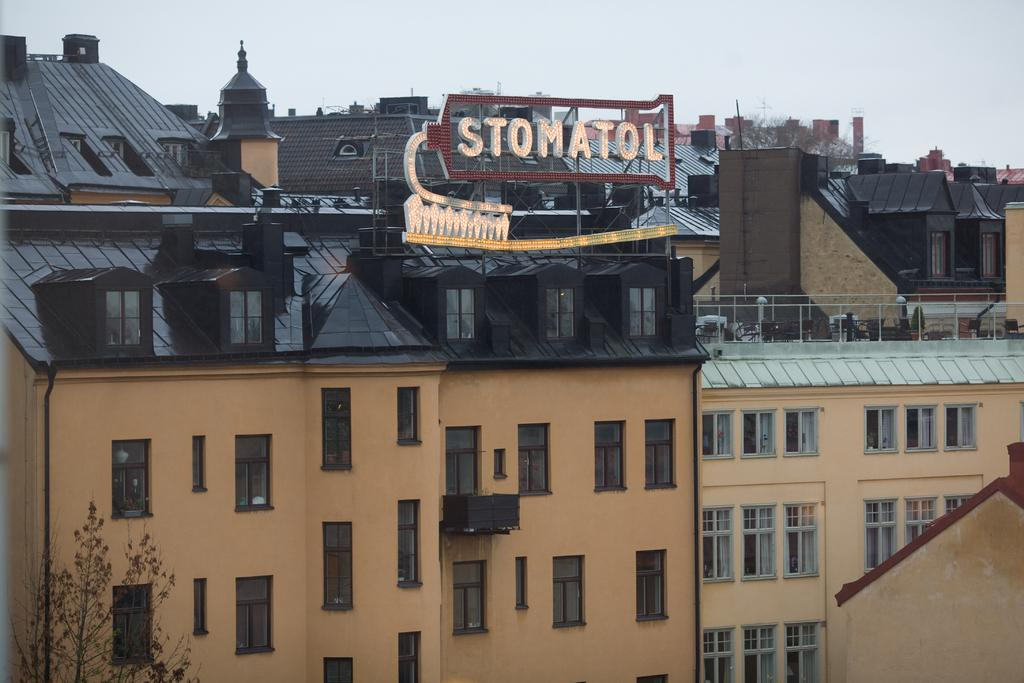What color are the roofs of the buildings in the image? The roofs of the buildings in the image are black. What type of vegetation can be seen in the image? There are dried trees in the image. What can be seen in the background of the image? The sky is visible in the background of the image. What word is written on the trunk of the dried tree in the image? There is no word written on the trunk of the dried tree in the image, as it is a dried tree and not a surface for writing. 